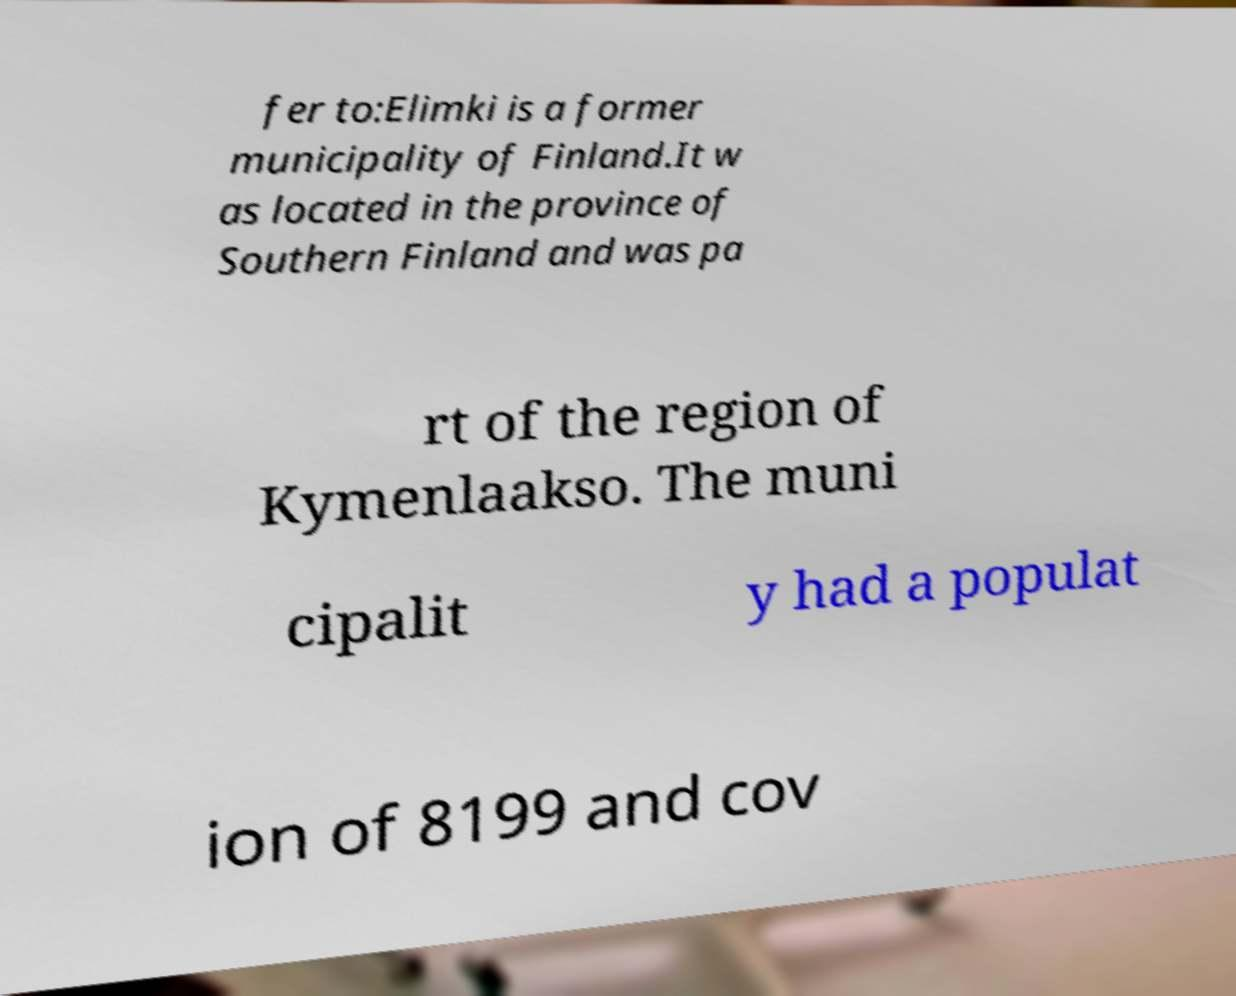Could you extract and type out the text from this image? fer to:Elimki is a former municipality of Finland.It w as located in the province of Southern Finland and was pa rt of the region of Kymenlaakso. The muni cipalit y had a populat ion of 8199 and cov 